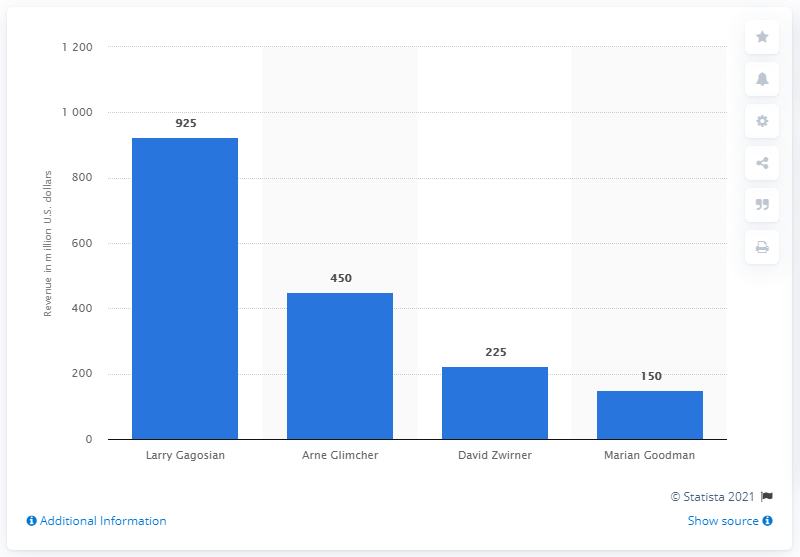Specify some key components in this picture. In 2013, Larry Gagosian's estimated revenue was approximately 925. The director of the Gagosian Gallery is Larry Gagosian. 